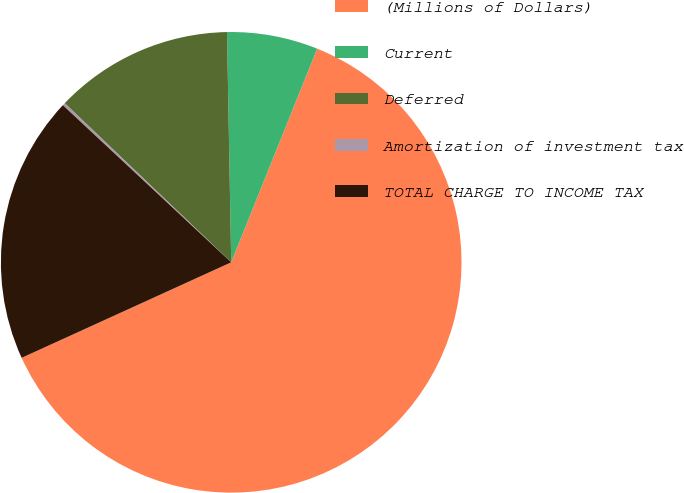Convert chart to OTSL. <chart><loc_0><loc_0><loc_500><loc_500><pie_chart><fcel>(Millions of Dollars)<fcel>Current<fcel>Deferred<fcel>Amortization of investment tax<fcel>TOTAL CHARGE TO INCOME TAX<nl><fcel>62.11%<fcel>6.38%<fcel>12.57%<fcel>0.19%<fcel>18.76%<nl></chart> 